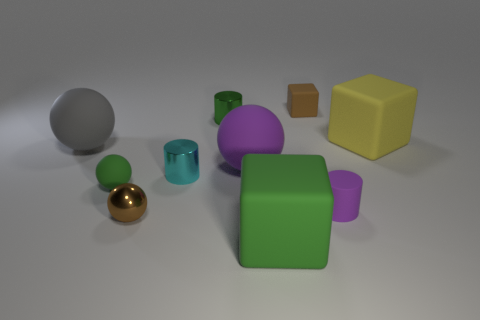What is the green thing that is both in front of the cyan cylinder and to the left of the big green cube made of? The green object in question appears to be a smaller cube with a slightly different shade than the larger green cube. Its material is not explicitly discernible from the image, but given the context of a 3D rendered scene, it is likely to be a digital model textured to simulate a plastic-like material, rather than rubber. 